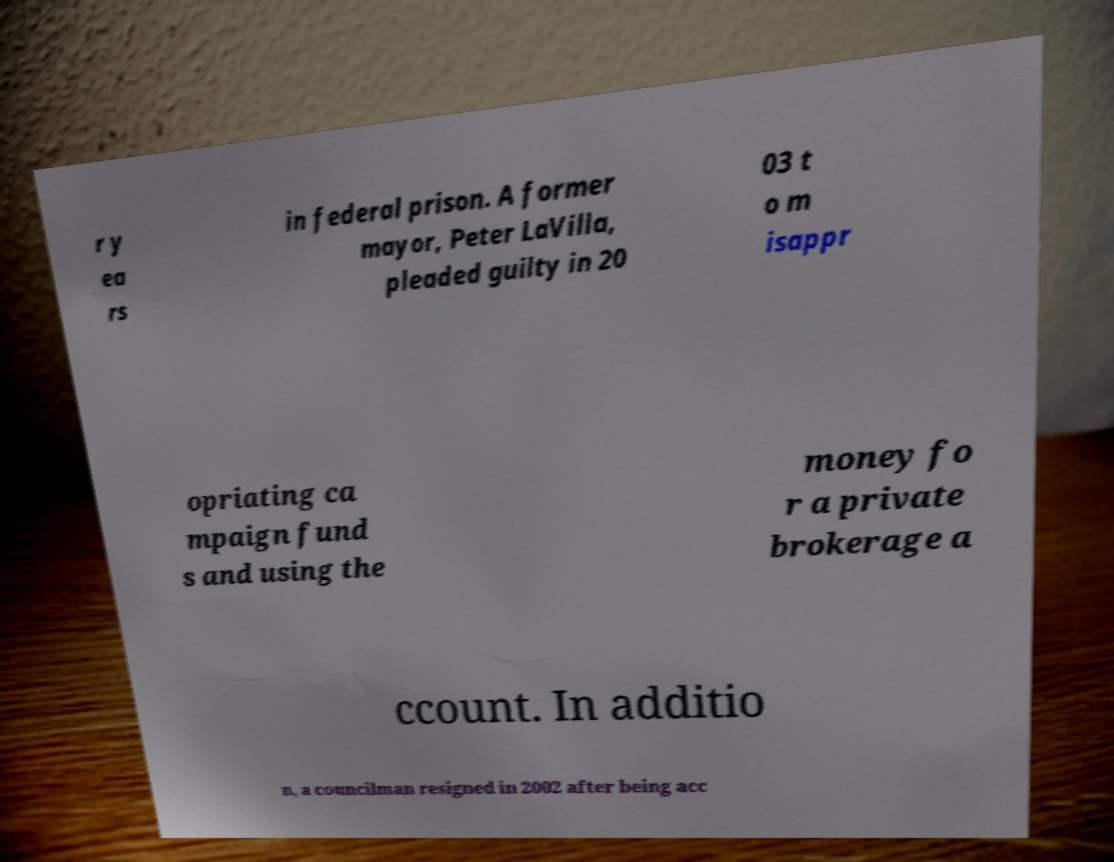What messages or text are displayed in this image? I need them in a readable, typed format. r y ea rs in federal prison. A former mayor, Peter LaVilla, pleaded guilty in 20 03 t o m isappr opriating ca mpaign fund s and using the money fo r a private brokerage a ccount. In additio n, a councilman resigned in 2002 after being acc 